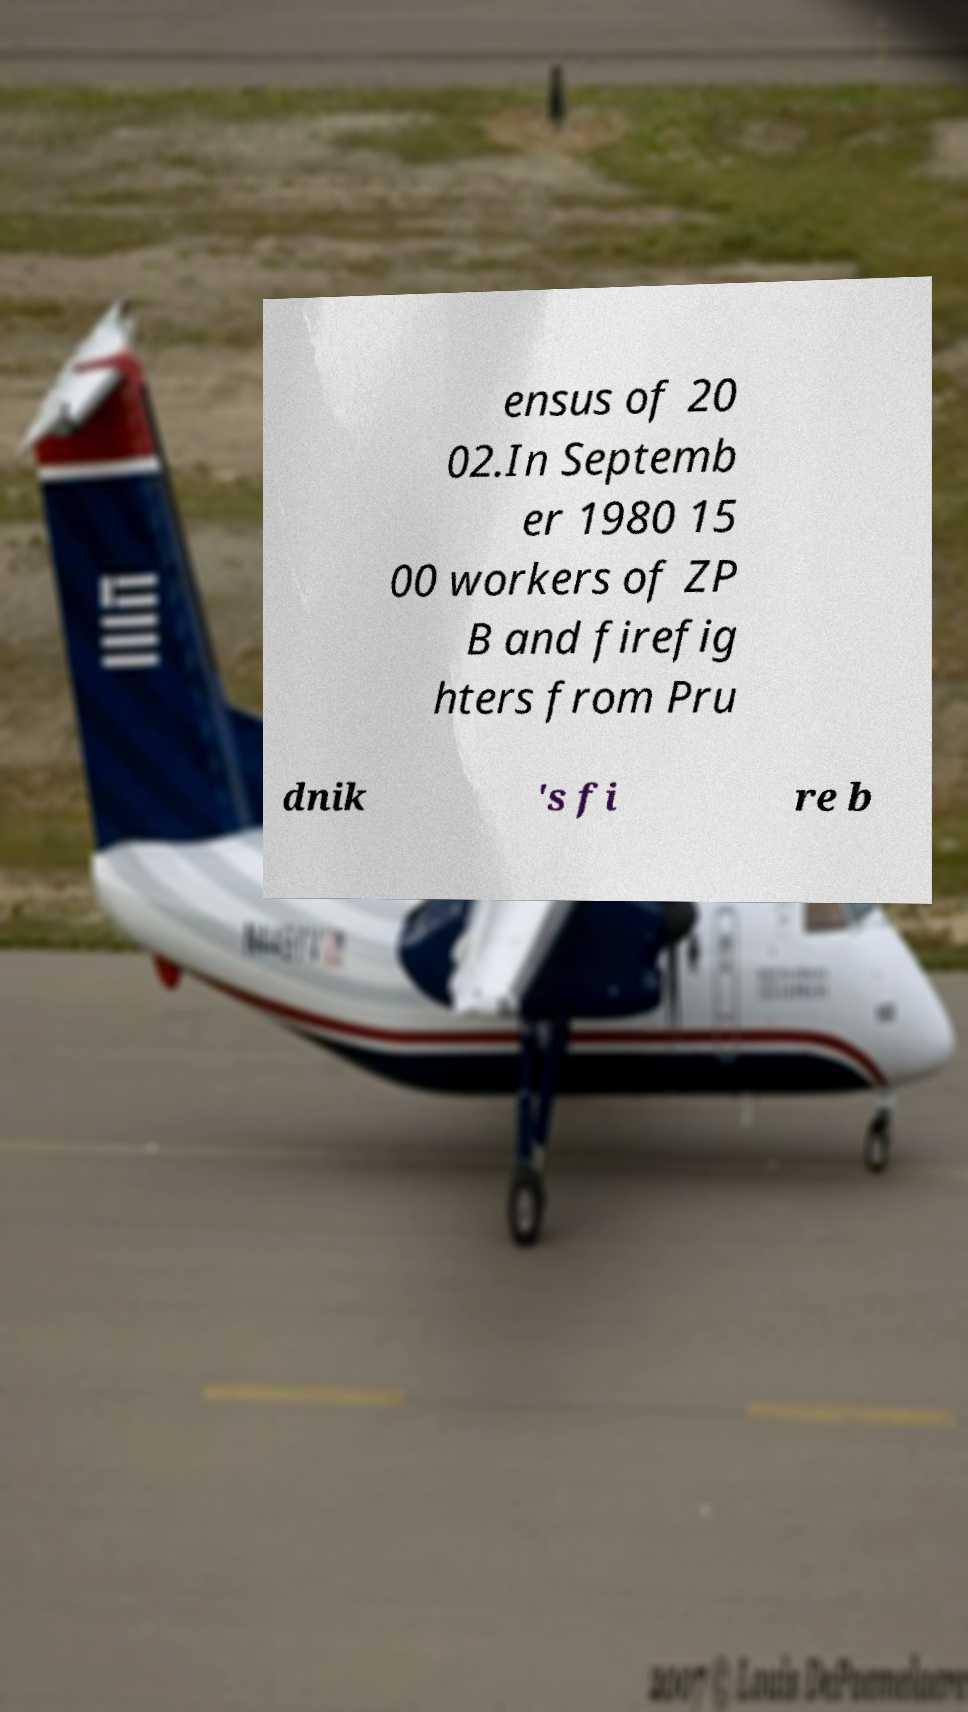Could you extract and type out the text from this image? ensus of 20 02.In Septemb er 1980 15 00 workers of ZP B and firefig hters from Pru dnik 's fi re b 